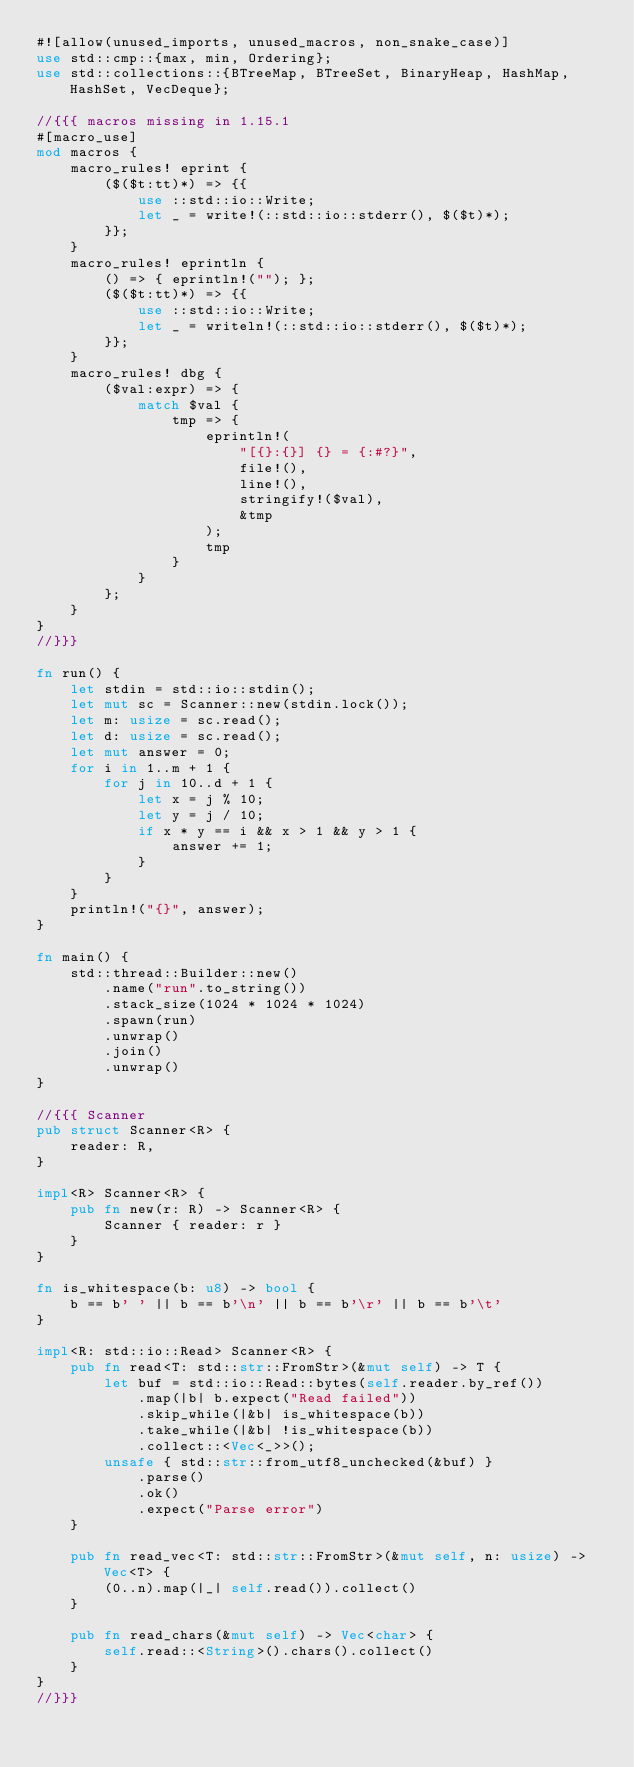Convert code to text. <code><loc_0><loc_0><loc_500><loc_500><_Rust_>#![allow(unused_imports, unused_macros, non_snake_case)]
use std::cmp::{max, min, Ordering};
use std::collections::{BTreeMap, BTreeSet, BinaryHeap, HashMap, HashSet, VecDeque};

//{{{ macros missing in 1.15.1
#[macro_use]
mod macros {
    macro_rules! eprint {
        ($($t:tt)*) => {{
            use ::std::io::Write;
            let _ = write!(::std::io::stderr(), $($t)*);
        }};
    }
    macro_rules! eprintln {
        () => { eprintln!(""); };
        ($($t:tt)*) => {{
            use ::std::io::Write;
            let _ = writeln!(::std::io::stderr(), $($t)*);
        }};
    }
    macro_rules! dbg {
        ($val:expr) => {
            match $val {
                tmp => {
                    eprintln!(
                        "[{}:{}] {} = {:#?}",
                        file!(),
                        line!(),
                        stringify!($val),
                        &tmp
                    );
                    tmp
                }
            }
        };
    }
}
//}}}

fn run() {
    let stdin = std::io::stdin();
    let mut sc = Scanner::new(stdin.lock());
    let m: usize = sc.read();
    let d: usize = sc.read();
    let mut answer = 0;
    for i in 1..m + 1 {
        for j in 10..d + 1 {
            let x = j % 10;
            let y = j / 10;
            if x * y == i && x > 1 && y > 1 {
                answer += 1;
            }
        }
    }
    println!("{}", answer);
}

fn main() {
    std::thread::Builder::new()
        .name("run".to_string())
        .stack_size(1024 * 1024 * 1024)
        .spawn(run)
        .unwrap()
        .join()
        .unwrap()
}

//{{{ Scanner
pub struct Scanner<R> {
    reader: R,
}

impl<R> Scanner<R> {
    pub fn new(r: R) -> Scanner<R> {
        Scanner { reader: r }
    }
}

fn is_whitespace(b: u8) -> bool {
    b == b' ' || b == b'\n' || b == b'\r' || b == b'\t'
}

impl<R: std::io::Read> Scanner<R> {
    pub fn read<T: std::str::FromStr>(&mut self) -> T {
        let buf = std::io::Read::bytes(self.reader.by_ref())
            .map(|b| b.expect("Read failed"))
            .skip_while(|&b| is_whitespace(b))
            .take_while(|&b| !is_whitespace(b))
            .collect::<Vec<_>>();
        unsafe { std::str::from_utf8_unchecked(&buf) }
            .parse()
            .ok()
            .expect("Parse error")
    }

    pub fn read_vec<T: std::str::FromStr>(&mut self, n: usize) -> Vec<T> {
        (0..n).map(|_| self.read()).collect()
    }

    pub fn read_chars(&mut self) -> Vec<char> {
        self.read::<String>().chars().collect()
    }
}
//}}}
</code> 